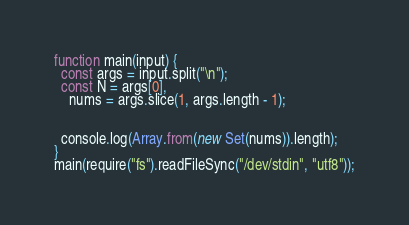<code> <loc_0><loc_0><loc_500><loc_500><_JavaScript_>function main(input) {
  const args = input.split("\n");
  const N = args[0],
    nums = args.slice(1, args.length - 1);

  
  console.log(Array.from(new Set(nums)).length);
}
main(require("fs").readFileSync("/dev/stdin", "utf8"));</code> 